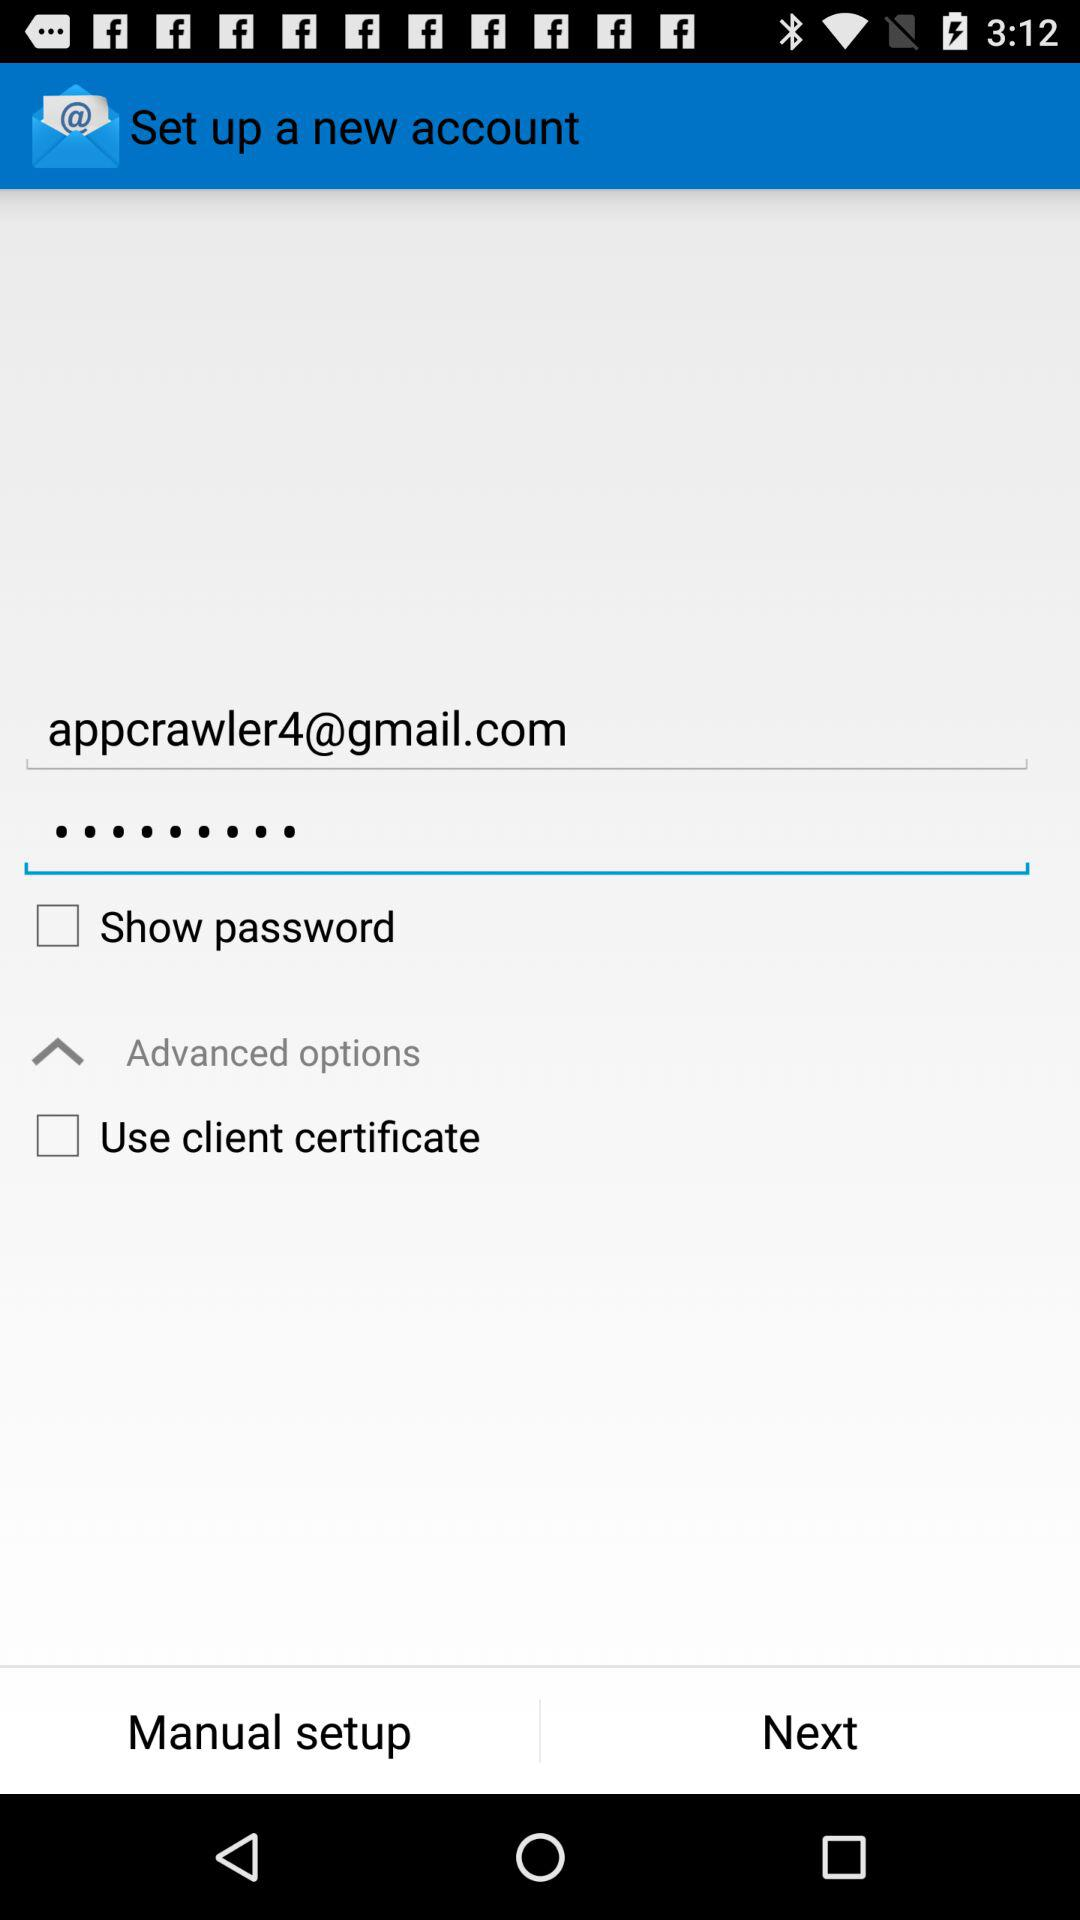What's the Gmail address? The Gmail address is appcrawler4@gmail.com. 